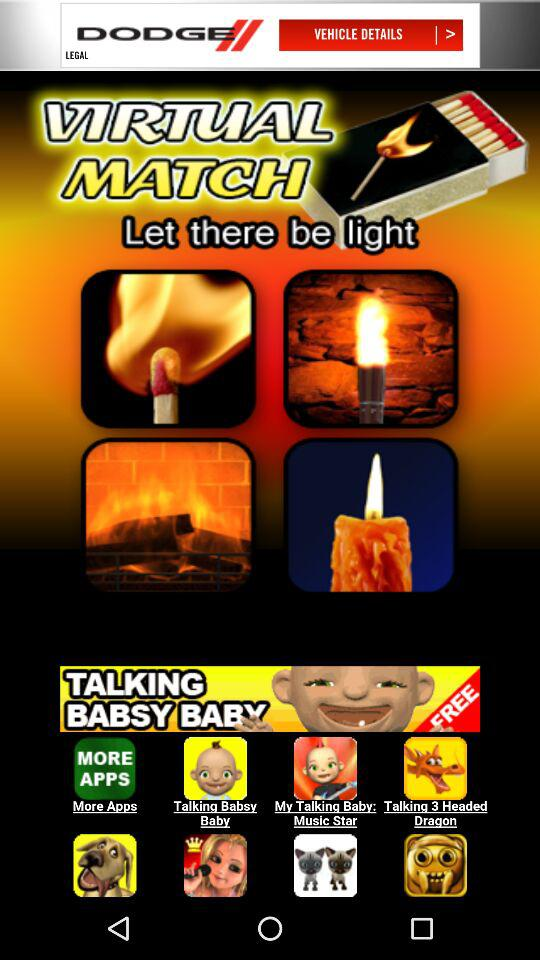What is the name of the application? The name of the application is "Virtual Lighter". 